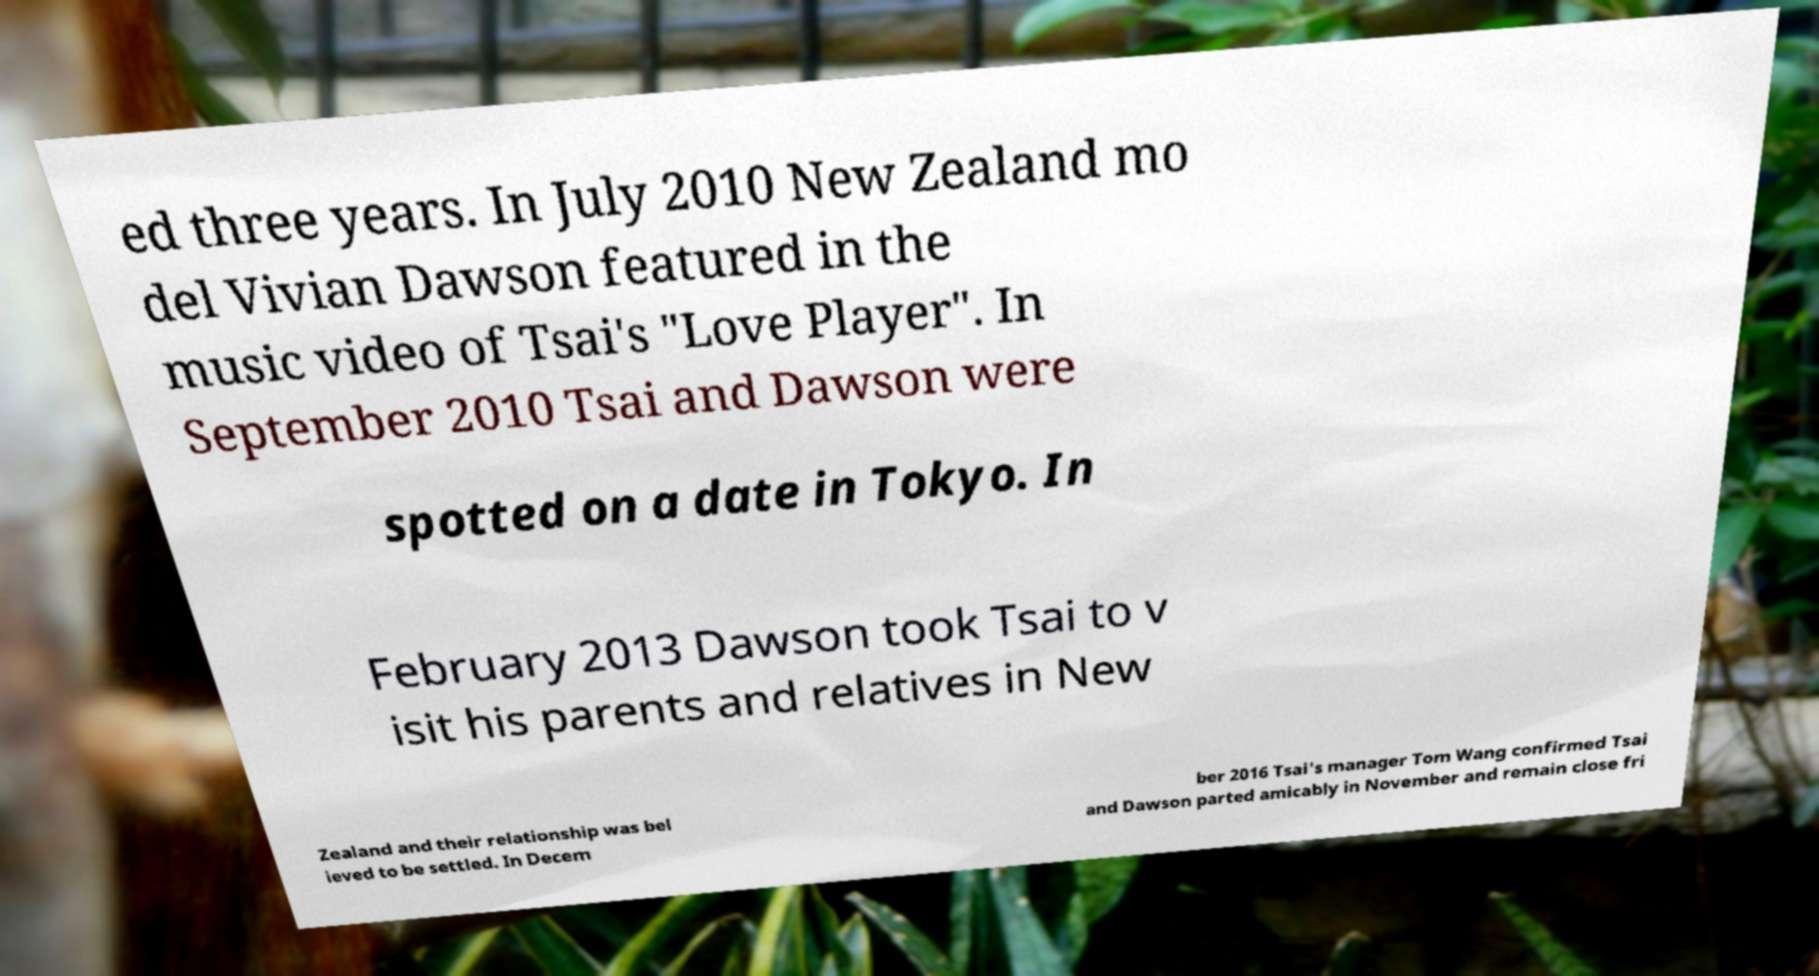For documentation purposes, I need the text within this image transcribed. Could you provide that? ed three years. In July 2010 New Zealand mo del Vivian Dawson featured in the music video of Tsai's "Love Player". In September 2010 Tsai and Dawson were spotted on a date in Tokyo. In February 2013 Dawson took Tsai to v isit his parents and relatives in New Zealand and their relationship was bel ieved to be settled. In Decem ber 2016 Tsai's manager Tom Wang confirmed Tsai and Dawson parted amicably in November and remain close fri 